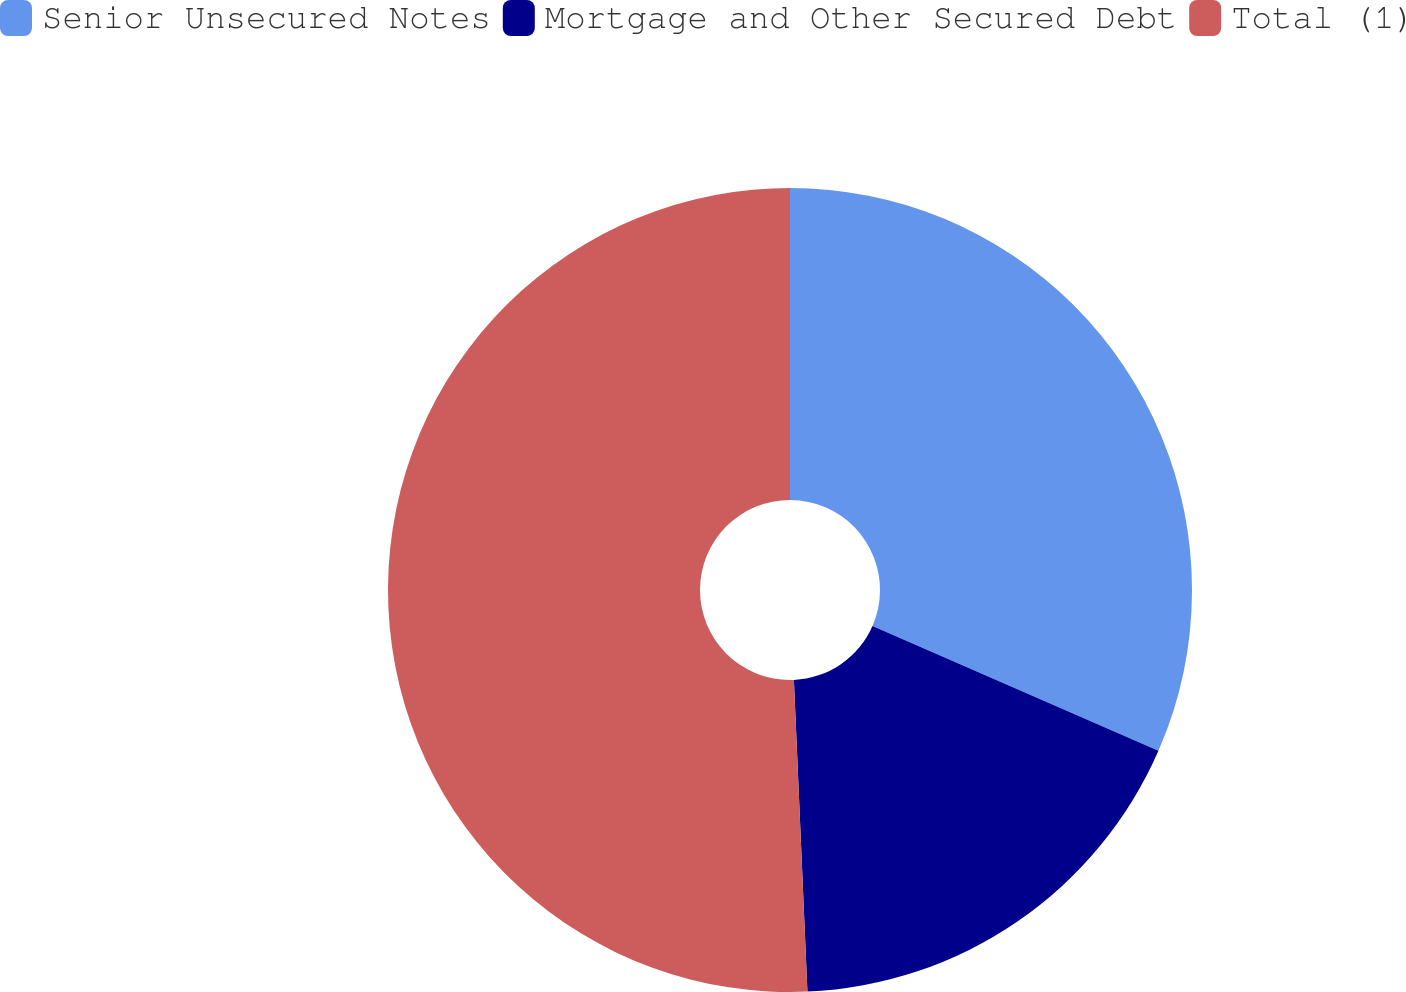<chart> <loc_0><loc_0><loc_500><loc_500><pie_chart><fcel>Senior Unsecured Notes<fcel>Mortgage and Other Secured Debt<fcel>Total (1)<nl><fcel>31.55%<fcel>17.76%<fcel>50.69%<nl></chart> 